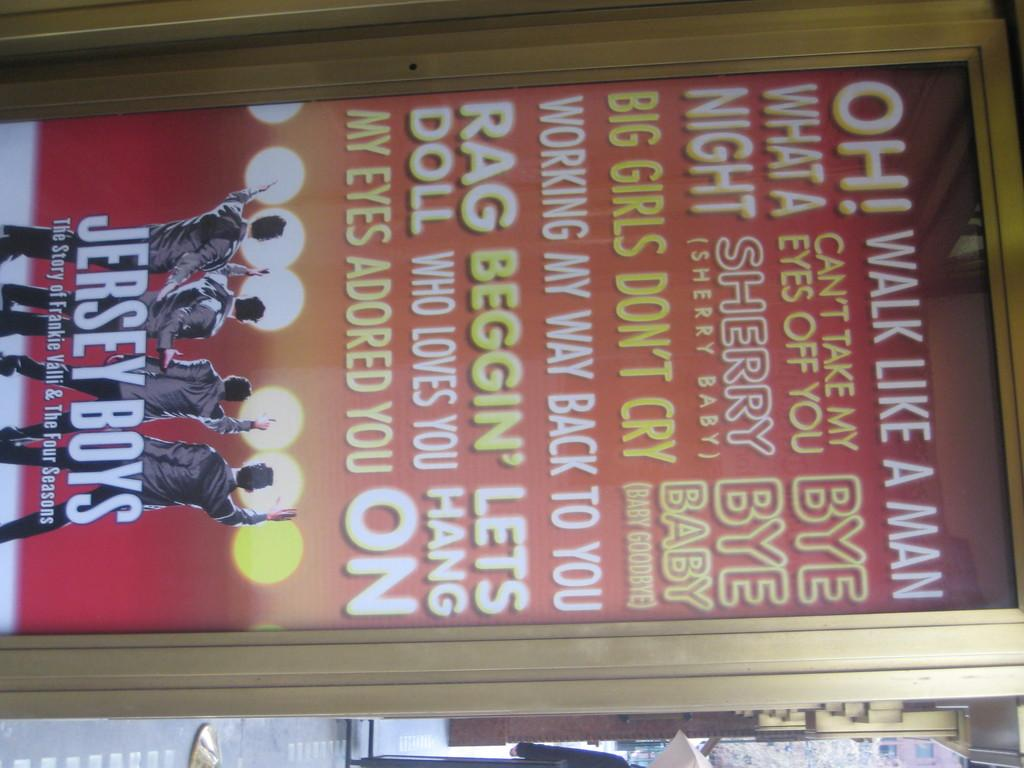<image>
Summarize the visual content of the image. A poster advertises Jersey Boys, with various lyrics in different fonts all over the poster, and four male singers are seen performing in identical outfits at the bottom. 